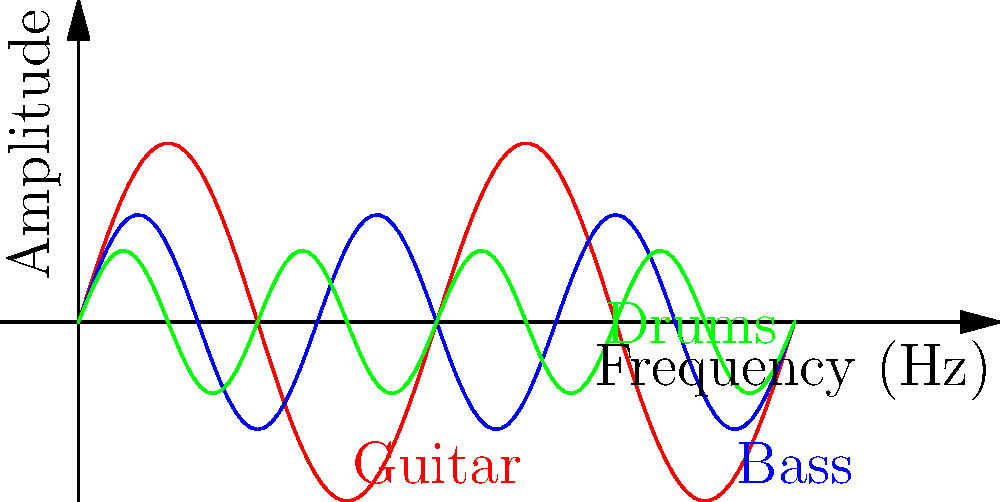In a brutal death metal breakdown, you notice different resonant frequencies from various instruments. The graph shows simplified waveforms for a guitar (red), bass (blue), and drums (green). Which instrument has the highest fundamental frequency, and how does this relate to its physical structure? To determine which instrument has the highest fundamental frequency, we need to analyze the waveforms:

1. The fundamental frequency is inversely proportional to the wavelength of the oscillation.
2. Count the number of complete cycles within the given range for each instrument:
   - Guitar (red): 2 complete cycles
   - Bass (blue): 3 complete cycles
   - Drums (green): 4 complete cycles

3. The instrument with the most cycles has the highest fundamental frequency, which is the drums (green).

4. Relationship to physical structure:
   - Drums have smaller, tighter membranes or shells, allowing for higher frequencies.
   - The guitar has longer strings, resulting in lower frequencies than drums but higher than bass.
   - The bass has the longest strings, producing the lowest fundamental frequency of the three.

5. The frequency ($f$) of a vibrating string is given by:

   $$f = \frac{1}{2L} \sqrt{\frac{T}{\mu}}$$

   Where $L$ is the string length, $T$ is tension, and $\mu$ is the linear density.

6. For drums, the frequency depends on the membrane's tension and size:

   $$f = \frac{1}{2\pi R} \sqrt{\frac{T}{\sigma}}$$

   Where $R$ is the radius, $T$ is tension, and $\sigma$ is the surface density.

These equations explain why smaller, tighter instruments produce higher frequencies.
Answer: Drums; smaller size and higher tension allow for higher frequencies. 